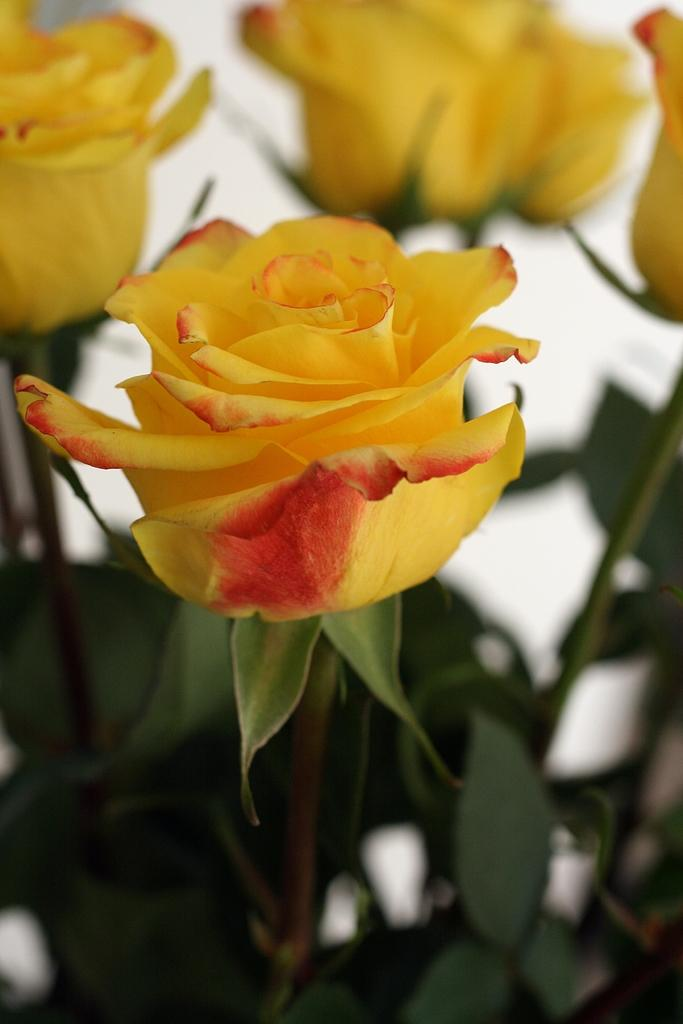What type of flowers are in the image? There are roses in the image. What color are the roses in the image? The roses are yellow in color. What else can be seen in the image besides the roses? There are leaves in the image. How many beds are visible in the image? There are no beds present in the image; it features roses and leaves. 